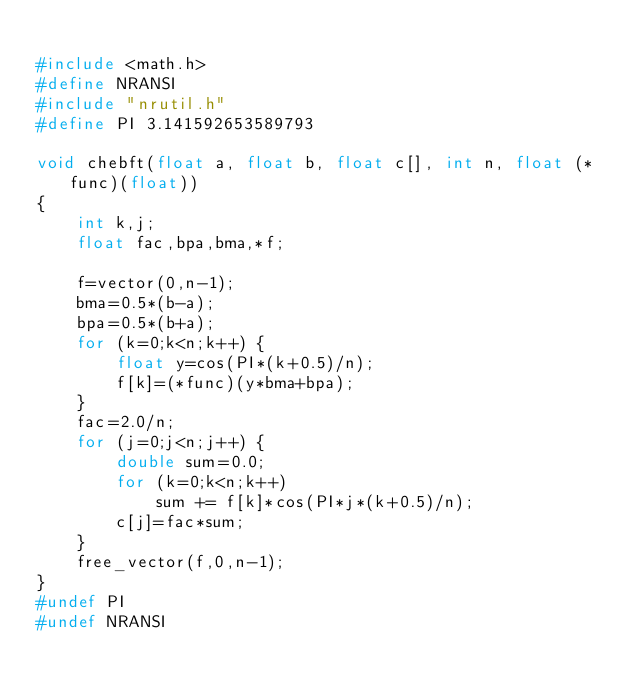Convert code to text. <code><loc_0><loc_0><loc_500><loc_500><_C_>
#include <math.h>
#define NRANSI
#include "nrutil.h"
#define PI 3.141592653589793

void chebft(float a, float b, float c[], int n, float (*func)(float))
{
	int k,j;
	float fac,bpa,bma,*f;

	f=vector(0,n-1);
	bma=0.5*(b-a);
	bpa=0.5*(b+a);
	for (k=0;k<n;k++) {
		float y=cos(PI*(k+0.5)/n);
		f[k]=(*func)(y*bma+bpa);
	}
	fac=2.0/n;
	for (j=0;j<n;j++) {
		double sum=0.0;
		for (k=0;k<n;k++)
			sum += f[k]*cos(PI*j*(k+0.5)/n);
		c[j]=fac*sum;
	}
	free_vector(f,0,n-1);
}
#undef PI
#undef NRANSI
</code> 